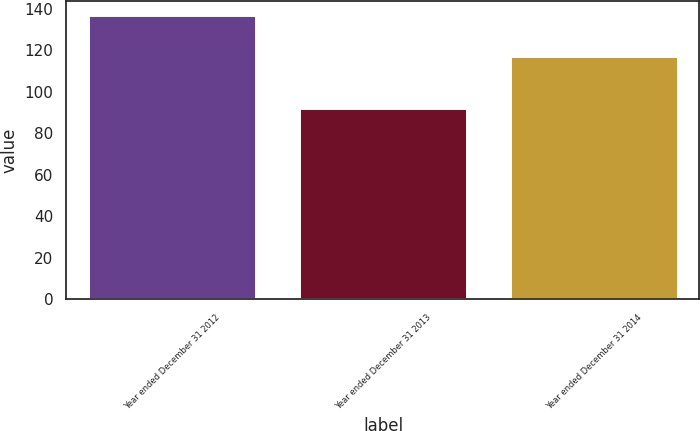<chart> <loc_0><loc_0><loc_500><loc_500><bar_chart><fcel>Year ended December 31 2012<fcel>Year ended December 31 2013<fcel>Year ended December 31 2014<nl><fcel>137<fcel>92<fcel>117<nl></chart> 